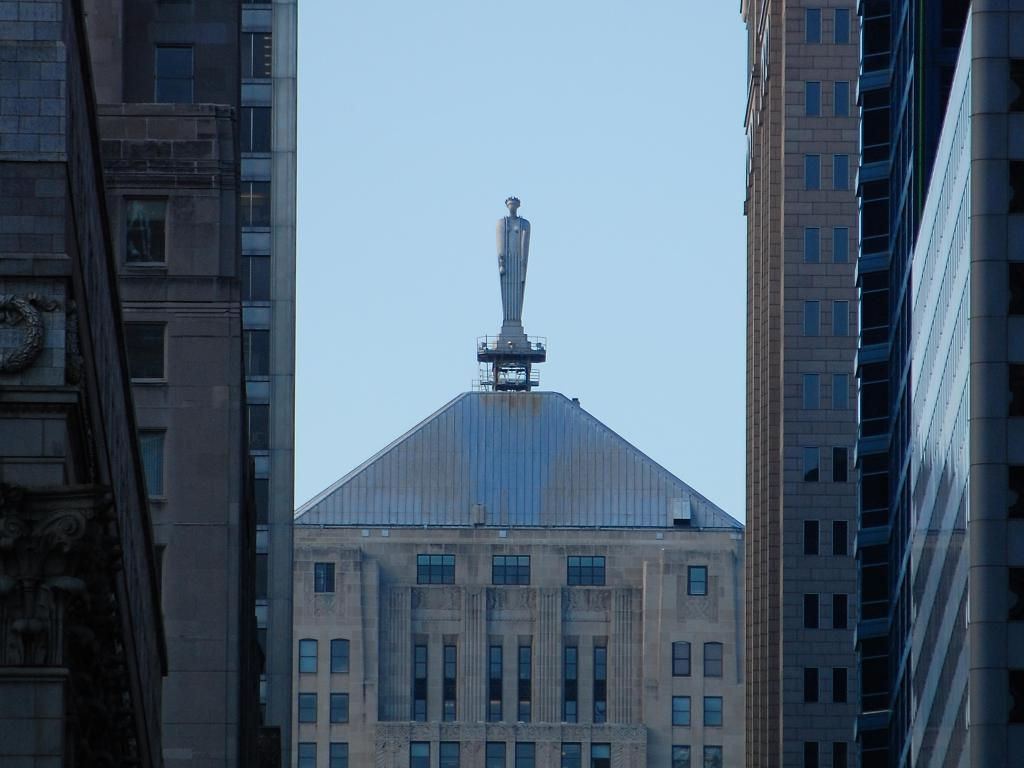What type of structures are located in the foreground of the image? There are buildings in the foreground of the image. What can be seen in the center of the image? There is a building and a statue in the center of the image. What is visible at the top of the image? The sky is visible at the top of the image. What is the condition of the statue's teeth in the image? There is no statue with teeth present in the image. What type of work is being done on the building in the center of the image? There is no indication of any work being done on the building in the image. 